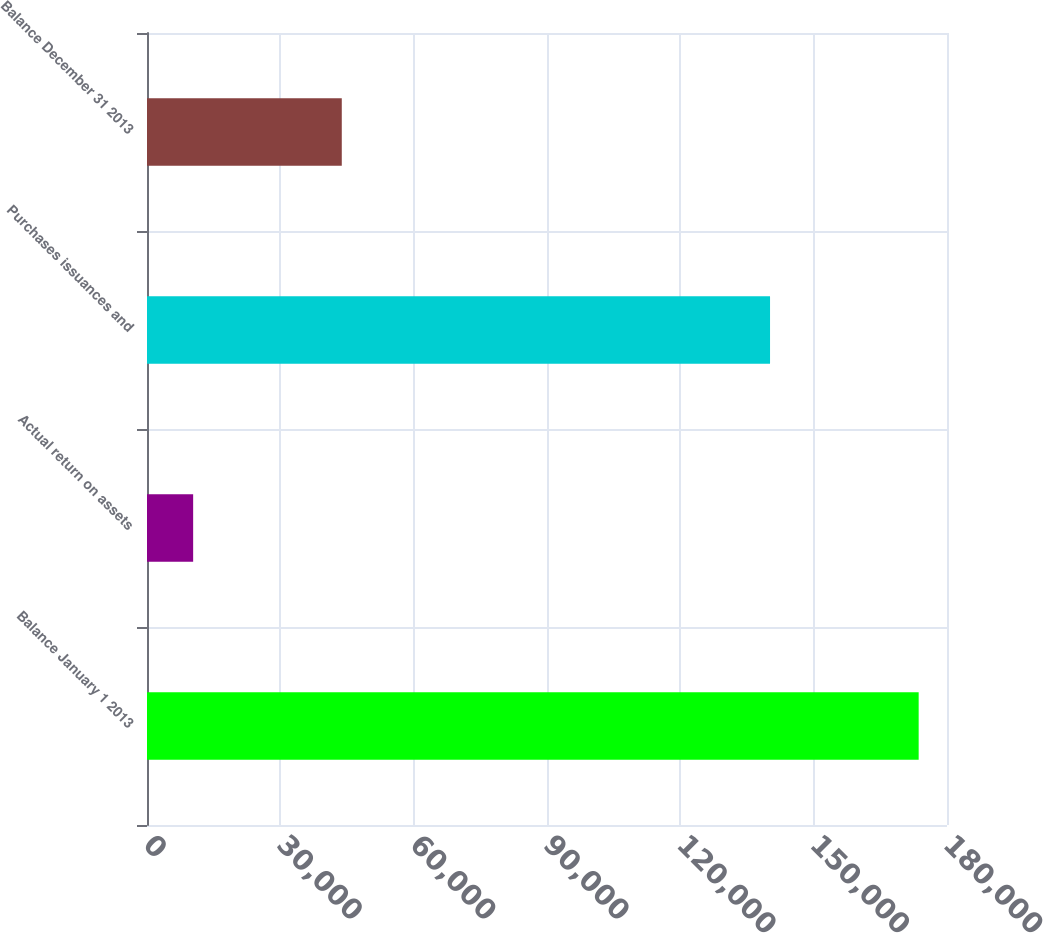Convert chart. <chart><loc_0><loc_0><loc_500><loc_500><bar_chart><fcel>Balance January 1 2013<fcel>Actual return on assets<fcel>Purchases issuances and<fcel>Balance December 31 2013<nl><fcel>173625<fcel>10384<fcel>140184<fcel>43825<nl></chart> 